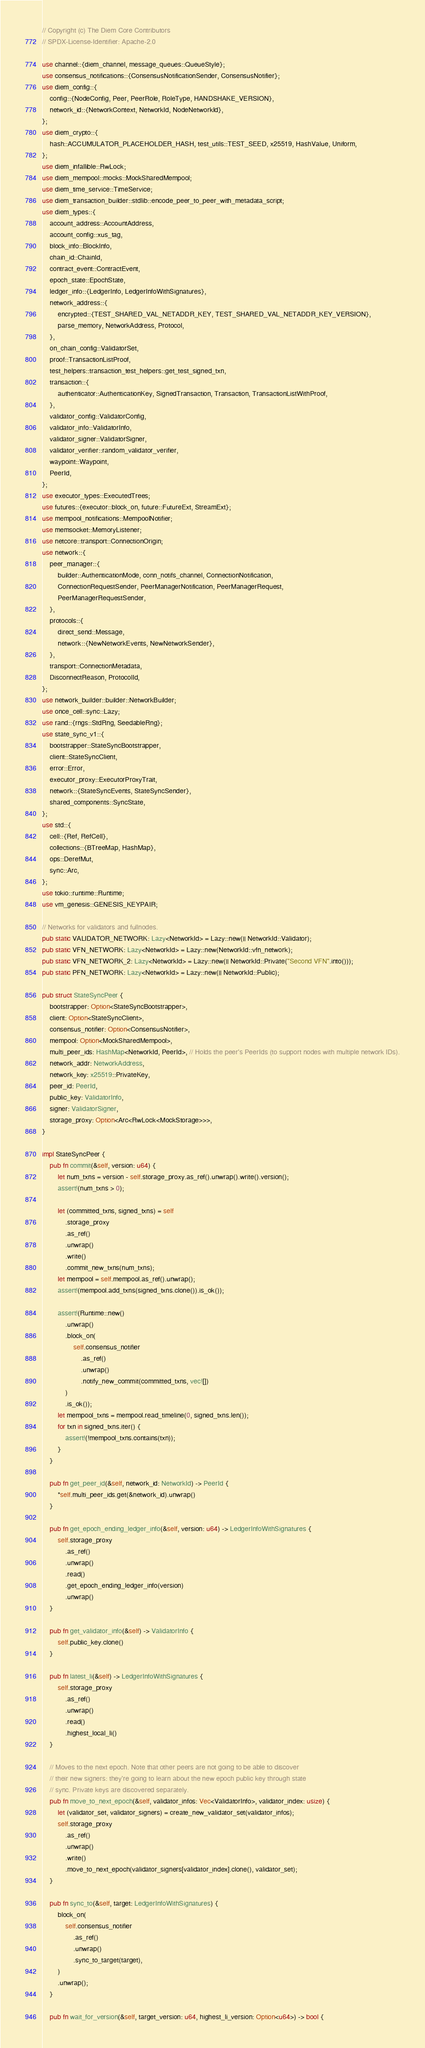Convert code to text. <code><loc_0><loc_0><loc_500><loc_500><_Rust_>// Copyright (c) The Diem Core Contributors
// SPDX-License-Identifier: Apache-2.0

use channel::{diem_channel, message_queues::QueueStyle};
use consensus_notifications::{ConsensusNotificationSender, ConsensusNotifier};
use diem_config::{
    config::{NodeConfig, Peer, PeerRole, RoleType, HANDSHAKE_VERSION},
    network_id::{NetworkContext, NetworkId, NodeNetworkId},
};
use diem_crypto::{
    hash::ACCUMULATOR_PLACEHOLDER_HASH, test_utils::TEST_SEED, x25519, HashValue, Uniform,
};
use diem_infallible::RwLock;
use diem_mempool::mocks::MockSharedMempool;
use diem_time_service::TimeService;
use diem_transaction_builder::stdlib::encode_peer_to_peer_with_metadata_script;
use diem_types::{
    account_address::AccountAddress,
    account_config::xus_tag,
    block_info::BlockInfo,
    chain_id::ChainId,
    contract_event::ContractEvent,
    epoch_state::EpochState,
    ledger_info::{LedgerInfo, LedgerInfoWithSignatures},
    network_address::{
        encrypted::{TEST_SHARED_VAL_NETADDR_KEY, TEST_SHARED_VAL_NETADDR_KEY_VERSION},
        parse_memory, NetworkAddress, Protocol,
    },
    on_chain_config::ValidatorSet,
    proof::TransactionListProof,
    test_helpers::transaction_test_helpers::get_test_signed_txn,
    transaction::{
        authenticator::AuthenticationKey, SignedTransaction, Transaction, TransactionListWithProof,
    },
    validator_config::ValidatorConfig,
    validator_info::ValidatorInfo,
    validator_signer::ValidatorSigner,
    validator_verifier::random_validator_verifier,
    waypoint::Waypoint,
    PeerId,
};
use executor_types::ExecutedTrees;
use futures::{executor::block_on, future::FutureExt, StreamExt};
use mempool_notifications::MempoolNotifier;
use memsocket::MemoryListener;
use netcore::transport::ConnectionOrigin;
use network::{
    peer_manager::{
        builder::AuthenticationMode, conn_notifs_channel, ConnectionNotification,
        ConnectionRequestSender, PeerManagerNotification, PeerManagerRequest,
        PeerManagerRequestSender,
    },
    protocols::{
        direct_send::Message,
        network::{NewNetworkEvents, NewNetworkSender},
    },
    transport::ConnectionMetadata,
    DisconnectReason, ProtocolId,
};
use network_builder::builder::NetworkBuilder;
use once_cell::sync::Lazy;
use rand::{rngs::StdRng, SeedableRng};
use state_sync_v1::{
    bootstrapper::StateSyncBootstrapper,
    client::StateSyncClient,
    error::Error,
    executor_proxy::ExecutorProxyTrait,
    network::{StateSyncEvents, StateSyncSender},
    shared_components::SyncState,
};
use std::{
    cell::{Ref, RefCell},
    collections::{BTreeMap, HashMap},
    ops::DerefMut,
    sync::Arc,
};
use tokio::runtime::Runtime;
use vm_genesis::GENESIS_KEYPAIR;

// Networks for validators and fullnodes.
pub static VALIDATOR_NETWORK: Lazy<NetworkId> = Lazy::new(|| NetworkId::Validator);
pub static VFN_NETWORK: Lazy<NetworkId> = Lazy::new(NetworkId::vfn_network);
pub static VFN_NETWORK_2: Lazy<NetworkId> = Lazy::new(|| NetworkId::Private("Second VFN".into()));
pub static PFN_NETWORK: Lazy<NetworkId> = Lazy::new(|| NetworkId::Public);

pub struct StateSyncPeer {
    bootstrapper: Option<StateSyncBootstrapper>,
    client: Option<StateSyncClient>,
    consensus_notifier: Option<ConsensusNotifier>,
    mempool: Option<MockSharedMempool>,
    multi_peer_ids: HashMap<NetworkId, PeerId>, // Holds the peer's PeerIds (to support nodes with multiple network IDs).
    network_addr: NetworkAddress,
    network_key: x25519::PrivateKey,
    peer_id: PeerId,
    public_key: ValidatorInfo,
    signer: ValidatorSigner,
    storage_proxy: Option<Arc<RwLock<MockStorage>>>,
}

impl StateSyncPeer {
    pub fn commit(&self, version: u64) {
        let num_txns = version - self.storage_proxy.as_ref().unwrap().write().version();
        assert!(num_txns > 0);

        let (committed_txns, signed_txns) = self
            .storage_proxy
            .as_ref()
            .unwrap()
            .write()
            .commit_new_txns(num_txns);
        let mempool = self.mempool.as_ref().unwrap();
        assert!(mempool.add_txns(signed_txns.clone()).is_ok());

        assert!(Runtime::new()
            .unwrap()
            .block_on(
                self.consensus_notifier
                    .as_ref()
                    .unwrap()
                    .notify_new_commit(committed_txns, vec![])
            )
            .is_ok());
        let mempool_txns = mempool.read_timeline(0, signed_txns.len());
        for txn in signed_txns.iter() {
            assert!(!mempool_txns.contains(txn));
        }
    }

    pub fn get_peer_id(&self, network_id: NetworkId) -> PeerId {
        *self.multi_peer_ids.get(&network_id).unwrap()
    }

    pub fn get_epoch_ending_ledger_info(&self, version: u64) -> LedgerInfoWithSignatures {
        self.storage_proxy
            .as_ref()
            .unwrap()
            .read()
            .get_epoch_ending_ledger_info(version)
            .unwrap()
    }

    pub fn get_validator_info(&self) -> ValidatorInfo {
        self.public_key.clone()
    }

    pub fn latest_li(&self) -> LedgerInfoWithSignatures {
        self.storage_proxy
            .as_ref()
            .unwrap()
            .read()
            .highest_local_li()
    }

    // Moves to the next epoch. Note that other peers are not going to be able to discover
    // their new signers: they're going to learn about the new epoch public key through state
    // sync. Private keys are discovered separately.
    pub fn move_to_next_epoch(&self, validator_infos: Vec<ValidatorInfo>, validator_index: usize) {
        let (validator_set, validator_signers) = create_new_validator_set(validator_infos);
        self.storage_proxy
            .as_ref()
            .unwrap()
            .write()
            .move_to_next_epoch(validator_signers[validator_index].clone(), validator_set);
    }

    pub fn sync_to(&self, target: LedgerInfoWithSignatures) {
        block_on(
            self.consensus_notifier
                .as_ref()
                .unwrap()
                .sync_to_target(target),
        )
        .unwrap();
    }

    pub fn wait_for_version(&self, target_version: u64, highest_li_version: Option<u64>) -> bool {</code> 